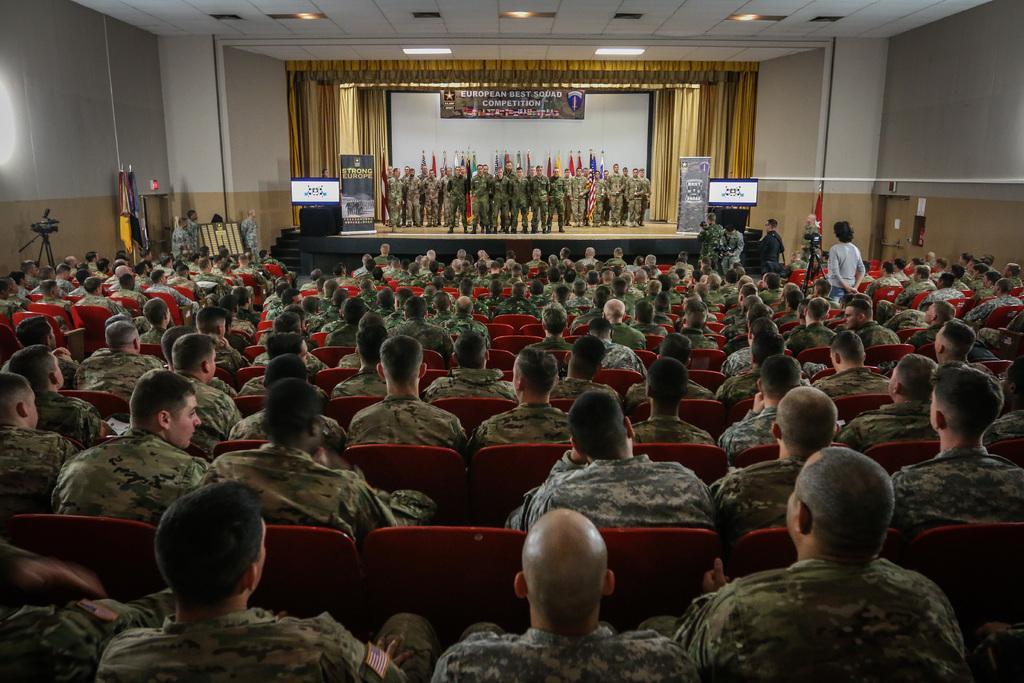Please provide a concise description of this image. It is an auditorium and inside the auditorium there are many soldiers sitting in the chairs and in front of them on the stage there are group of soldiers standing and behind them there are different countries flags and in the background there is a screen and gold curtain beside the screen. 